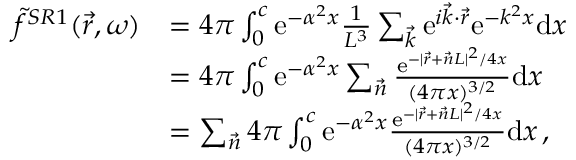<formula> <loc_0><loc_0><loc_500><loc_500>\begin{array} { r l } { \tilde { f } ^ { S R 1 } ( \vec { r } , \omega ) } & { = 4 \pi \int _ { 0 } ^ { c } e ^ { - \alpha ^ { 2 } x } \frac { 1 } { L ^ { 3 } } \sum _ { \vec { k } } e ^ { i \vec { k } \cdot \vec { r } } e ^ { - k ^ { 2 } x } d x } \\ & { = 4 \pi \int _ { 0 } ^ { c } e ^ { - \alpha ^ { 2 } x } \sum _ { \vec { n } } \frac { e ^ { - | \vec { r } + \vec { n } L | ^ { 2 } / 4 x } } { ( 4 \pi x ) ^ { 3 / 2 } } d x } \\ & { = \sum _ { \vec { n } } 4 \pi \int _ { 0 } ^ { c } e ^ { - \alpha ^ { 2 } x } \frac { e ^ { - | \vec { r } + \vec { n } L | ^ { 2 } / 4 x } } { ( 4 \pi x ) ^ { 3 / 2 } } d x \, , } \end{array}</formula> 